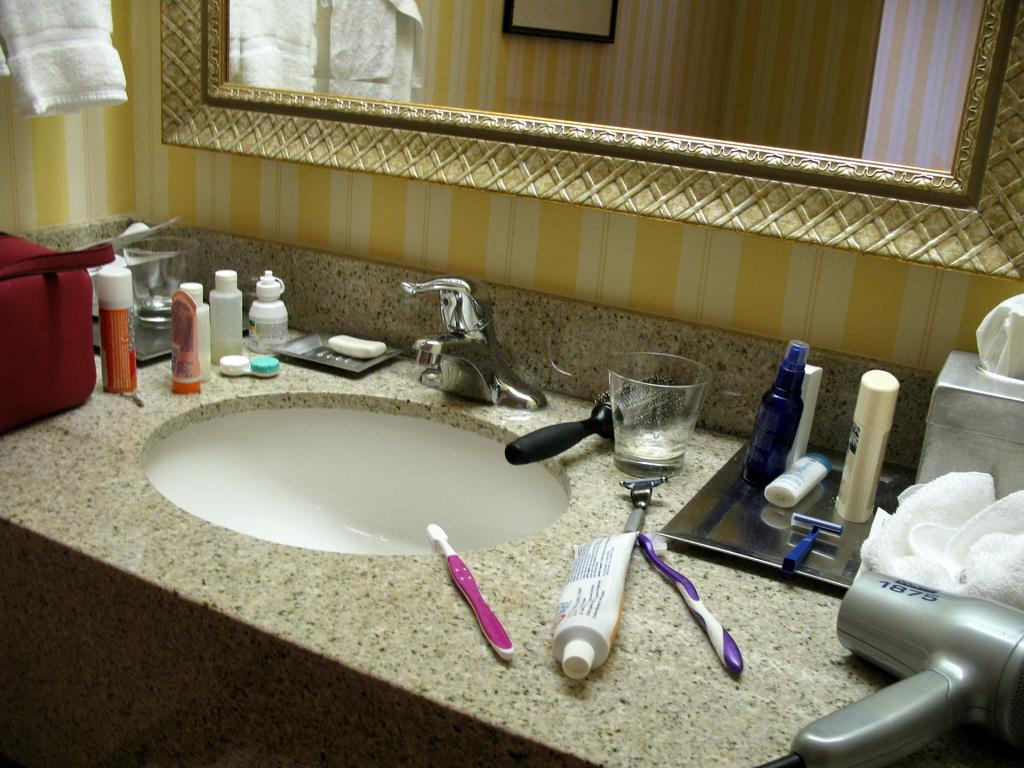What is the main object in the image? There is a washbasin in the image. What items related to dental hygiene can be seen in the image? There are toothbrushes and toothpaste in the image. What other objects are present in the image? There is a glass, a comb, a cloth, and a mirror in the image. How many people are laughing in the image? There are no people present in the image, so it is not possible to determine how many are laughing. 